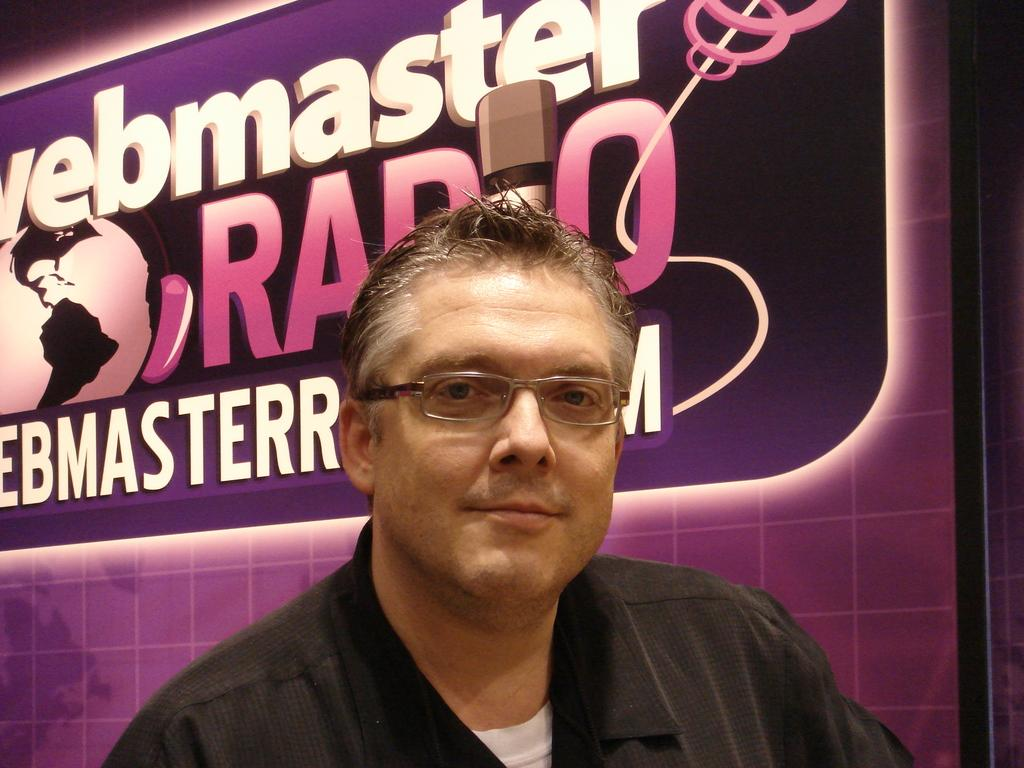Who is the main subject in the image? There is a man in the center of the image. What is the man wearing? The man is wearing a black shirt and spectacles. What can be seen in the background of the image? There is a board in the background of the image. What is written on the board? There is text visible on the board. What type of farm animals can be seen in the image? There are no farm animals present in the image. What discovery was made during the dinner in the image? There is no dinner or discovery depicted in the image; it features a man in the center with a board in the background. 